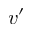<formula> <loc_0><loc_0><loc_500><loc_500>v ^ { \prime }</formula> 